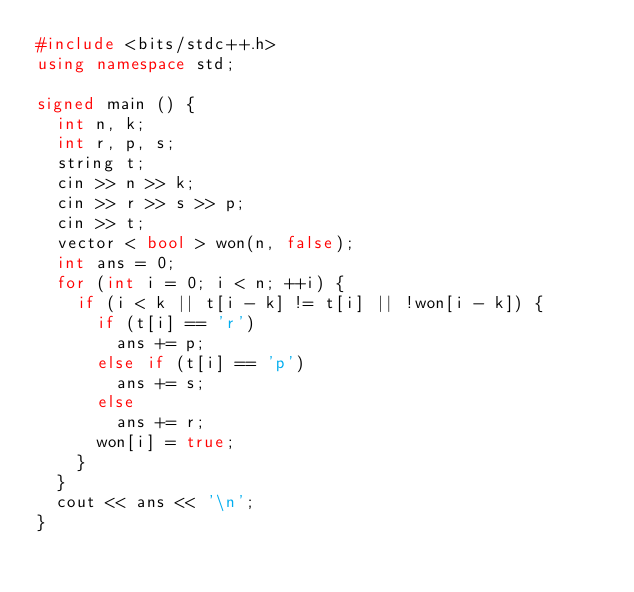<code> <loc_0><loc_0><loc_500><loc_500><_C++_>#include <bits/stdc++.h>
using namespace std;

signed main () {
	int n, k;
	int r, p, s;
	string t;
	cin >> n >> k;
	cin >> r >> s >> p;
	cin >> t;
	vector < bool > won(n, false);
	int ans = 0;
	for (int i = 0; i < n; ++i) {
		if (i < k || t[i - k] != t[i] || !won[i - k]) {
			if (t[i] == 'r')
				ans += p;
			else if (t[i] == 'p')
				ans += s;
			else
				ans += r;
			won[i] = true;
		}
	}
	cout << ans << '\n';
}
</code> 